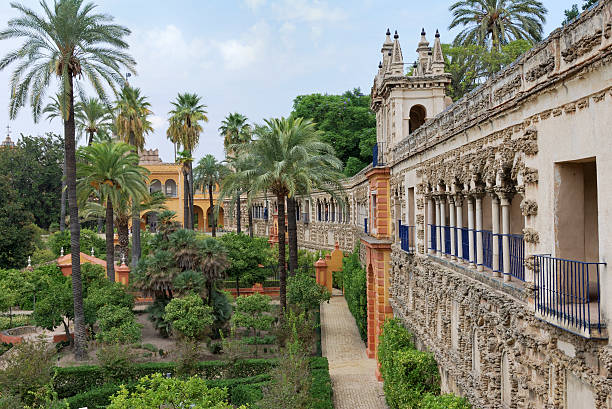What is this photo about? The photo offers a glimpse into a tranquil garden oasis, possibly within a historic or culturally significant site, shown by the intricate facade of the stone building on the right. Palm trees tower over meticulously manicured bushes and pathways, suggesting a well-maintained and designed landscape. This might be a public or private garden in a region that experiences warm weather, evident from the thriving palms. A mix of architectural styles suggests a history of diverse influences, while the blue-painted railings introduce a refreshing pop of color that contrasts with the natural and architectural earth tones. The presence of various walkways invites visitors to stroll and admire this peaceful, verdant space. 